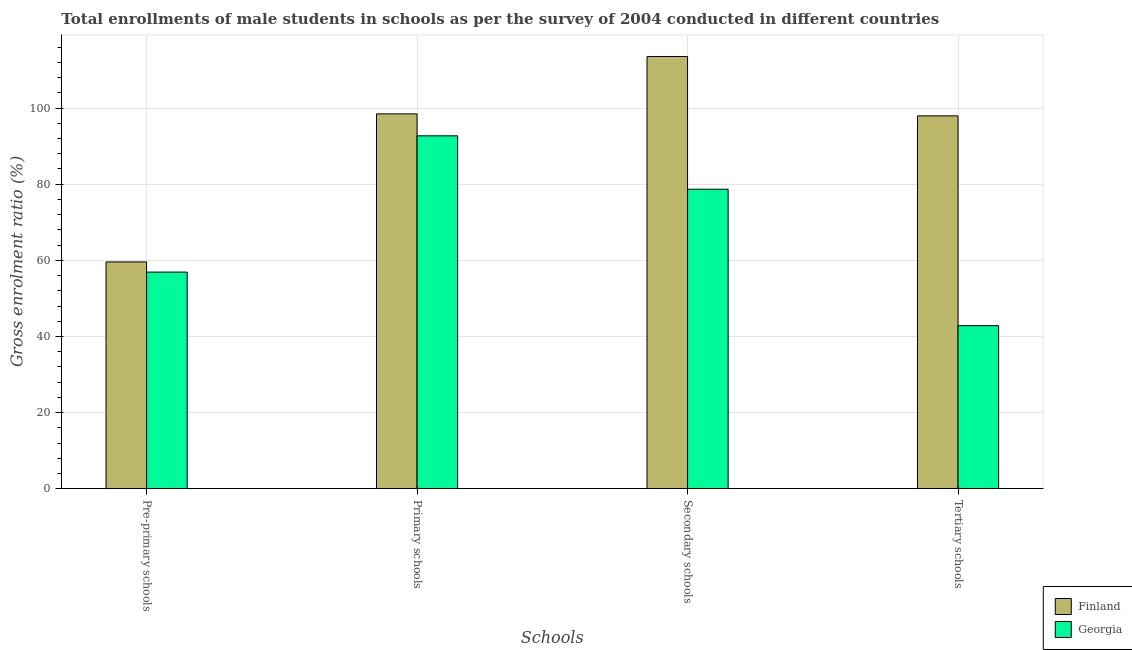How many groups of bars are there?
Make the answer very short. 4. Are the number of bars on each tick of the X-axis equal?
Your answer should be compact. Yes. How many bars are there on the 2nd tick from the right?
Provide a succinct answer. 2. What is the label of the 4th group of bars from the left?
Give a very brief answer. Tertiary schools. What is the gross enrolment ratio(male) in secondary schools in Finland?
Make the answer very short. 113.57. Across all countries, what is the maximum gross enrolment ratio(male) in primary schools?
Give a very brief answer. 98.49. Across all countries, what is the minimum gross enrolment ratio(male) in secondary schools?
Give a very brief answer. 78.69. In which country was the gross enrolment ratio(male) in tertiary schools maximum?
Provide a short and direct response. Finland. In which country was the gross enrolment ratio(male) in primary schools minimum?
Ensure brevity in your answer.  Georgia. What is the total gross enrolment ratio(male) in primary schools in the graph?
Keep it short and to the point. 191.2. What is the difference between the gross enrolment ratio(male) in tertiary schools in Georgia and that in Finland?
Keep it short and to the point. -55.13. What is the difference between the gross enrolment ratio(male) in secondary schools in Finland and the gross enrolment ratio(male) in pre-primary schools in Georgia?
Make the answer very short. 56.66. What is the average gross enrolment ratio(male) in primary schools per country?
Provide a succinct answer. 95.6. What is the difference between the gross enrolment ratio(male) in secondary schools and gross enrolment ratio(male) in tertiary schools in Finland?
Provide a short and direct response. 15.6. In how many countries, is the gross enrolment ratio(male) in primary schools greater than 48 %?
Ensure brevity in your answer.  2. What is the ratio of the gross enrolment ratio(male) in pre-primary schools in Finland to that in Georgia?
Your response must be concise. 1.05. Is the gross enrolment ratio(male) in primary schools in Finland less than that in Georgia?
Your response must be concise. No. What is the difference between the highest and the second highest gross enrolment ratio(male) in primary schools?
Provide a succinct answer. 5.77. What is the difference between the highest and the lowest gross enrolment ratio(male) in pre-primary schools?
Provide a short and direct response. 2.68. Is it the case that in every country, the sum of the gross enrolment ratio(male) in pre-primary schools and gross enrolment ratio(male) in primary schools is greater than the sum of gross enrolment ratio(male) in secondary schools and gross enrolment ratio(male) in tertiary schools?
Offer a terse response. No. What does the 1st bar from the left in Primary schools represents?
Provide a succinct answer. Finland. What does the 2nd bar from the right in Primary schools represents?
Ensure brevity in your answer.  Finland. How many bars are there?
Provide a succinct answer. 8. Are all the bars in the graph horizontal?
Offer a terse response. No. What is the difference between two consecutive major ticks on the Y-axis?
Give a very brief answer. 20. Where does the legend appear in the graph?
Ensure brevity in your answer.  Bottom right. How are the legend labels stacked?
Give a very brief answer. Vertical. What is the title of the graph?
Provide a short and direct response. Total enrollments of male students in schools as per the survey of 2004 conducted in different countries. What is the label or title of the X-axis?
Provide a succinct answer. Schools. What is the label or title of the Y-axis?
Give a very brief answer. Gross enrolment ratio (%). What is the Gross enrolment ratio (%) in Finland in Pre-primary schools?
Keep it short and to the point. 59.58. What is the Gross enrolment ratio (%) in Georgia in Pre-primary schools?
Provide a succinct answer. 56.91. What is the Gross enrolment ratio (%) in Finland in Primary schools?
Provide a short and direct response. 98.49. What is the Gross enrolment ratio (%) in Georgia in Primary schools?
Ensure brevity in your answer.  92.72. What is the Gross enrolment ratio (%) of Finland in Secondary schools?
Provide a succinct answer. 113.57. What is the Gross enrolment ratio (%) in Georgia in Secondary schools?
Provide a succinct answer. 78.69. What is the Gross enrolment ratio (%) in Finland in Tertiary schools?
Offer a terse response. 97.96. What is the Gross enrolment ratio (%) in Georgia in Tertiary schools?
Offer a very short reply. 42.83. Across all Schools, what is the maximum Gross enrolment ratio (%) in Finland?
Your response must be concise. 113.57. Across all Schools, what is the maximum Gross enrolment ratio (%) in Georgia?
Keep it short and to the point. 92.72. Across all Schools, what is the minimum Gross enrolment ratio (%) in Finland?
Give a very brief answer. 59.58. Across all Schools, what is the minimum Gross enrolment ratio (%) in Georgia?
Offer a very short reply. 42.83. What is the total Gross enrolment ratio (%) in Finland in the graph?
Offer a terse response. 369.59. What is the total Gross enrolment ratio (%) of Georgia in the graph?
Provide a succinct answer. 271.15. What is the difference between the Gross enrolment ratio (%) of Finland in Pre-primary schools and that in Primary schools?
Ensure brevity in your answer.  -38.9. What is the difference between the Gross enrolment ratio (%) in Georgia in Pre-primary schools and that in Primary schools?
Provide a succinct answer. -35.81. What is the difference between the Gross enrolment ratio (%) of Finland in Pre-primary schools and that in Secondary schools?
Give a very brief answer. -53.98. What is the difference between the Gross enrolment ratio (%) in Georgia in Pre-primary schools and that in Secondary schools?
Your answer should be compact. -21.78. What is the difference between the Gross enrolment ratio (%) of Finland in Pre-primary schools and that in Tertiary schools?
Your answer should be very brief. -38.38. What is the difference between the Gross enrolment ratio (%) of Georgia in Pre-primary schools and that in Tertiary schools?
Your response must be concise. 14.07. What is the difference between the Gross enrolment ratio (%) of Finland in Primary schools and that in Secondary schools?
Make the answer very short. -15.08. What is the difference between the Gross enrolment ratio (%) of Georgia in Primary schools and that in Secondary schools?
Provide a succinct answer. 14.03. What is the difference between the Gross enrolment ratio (%) in Finland in Primary schools and that in Tertiary schools?
Provide a succinct answer. 0.53. What is the difference between the Gross enrolment ratio (%) of Georgia in Primary schools and that in Tertiary schools?
Keep it short and to the point. 49.89. What is the difference between the Gross enrolment ratio (%) in Finland in Secondary schools and that in Tertiary schools?
Provide a short and direct response. 15.61. What is the difference between the Gross enrolment ratio (%) in Georgia in Secondary schools and that in Tertiary schools?
Your answer should be very brief. 35.86. What is the difference between the Gross enrolment ratio (%) in Finland in Pre-primary schools and the Gross enrolment ratio (%) in Georgia in Primary schools?
Provide a short and direct response. -33.14. What is the difference between the Gross enrolment ratio (%) of Finland in Pre-primary schools and the Gross enrolment ratio (%) of Georgia in Secondary schools?
Keep it short and to the point. -19.11. What is the difference between the Gross enrolment ratio (%) in Finland in Pre-primary schools and the Gross enrolment ratio (%) in Georgia in Tertiary schools?
Keep it short and to the point. 16.75. What is the difference between the Gross enrolment ratio (%) in Finland in Primary schools and the Gross enrolment ratio (%) in Georgia in Secondary schools?
Offer a terse response. 19.8. What is the difference between the Gross enrolment ratio (%) in Finland in Primary schools and the Gross enrolment ratio (%) in Georgia in Tertiary schools?
Give a very brief answer. 55.65. What is the difference between the Gross enrolment ratio (%) of Finland in Secondary schools and the Gross enrolment ratio (%) of Georgia in Tertiary schools?
Offer a very short reply. 70.73. What is the average Gross enrolment ratio (%) in Finland per Schools?
Give a very brief answer. 92.4. What is the average Gross enrolment ratio (%) in Georgia per Schools?
Ensure brevity in your answer.  67.79. What is the difference between the Gross enrolment ratio (%) of Finland and Gross enrolment ratio (%) of Georgia in Pre-primary schools?
Ensure brevity in your answer.  2.68. What is the difference between the Gross enrolment ratio (%) of Finland and Gross enrolment ratio (%) of Georgia in Primary schools?
Offer a very short reply. 5.77. What is the difference between the Gross enrolment ratio (%) in Finland and Gross enrolment ratio (%) in Georgia in Secondary schools?
Provide a short and direct response. 34.88. What is the difference between the Gross enrolment ratio (%) in Finland and Gross enrolment ratio (%) in Georgia in Tertiary schools?
Your answer should be compact. 55.13. What is the ratio of the Gross enrolment ratio (%) of Finland in Pre-primary schools to that in Primary schools?
Ensure brevity in your answer.  0.6. What is the ratio of the Gross enrolment ratio (%) of Georgia in Pre-primary schools to that in Primary schools?
Provide a short and direct response. 0.61. What is the ratio of the Gross enrolment ratio (%) in Finland in Pre-primary schools to that in Secondary schools?
Give a very brief answer. 0.52. What is the ratio of the Gross enrolment ratio (%) in Georgia in Pre-primary schools to that in Secondary schools?
Provide a short and direct response. 0.72. What is the ratio of the Gross enrolment ratio (%) in Finland in Pre-primary schools to that in Tertiary schools?
Provide a succinct answer. 0.61. What is the ratio of the Gross enrolment ratio (%) of Georgia in Pre-primary schools to that in Tertiary schools?
Give a very brief answer. 1.33. What is the ratio of the Gross enrolment ratio (%) of Finland in Primary schools to that in Secondary schools?
Make the answer very short. 0.87. What is the ratio of the Gross enrolment ratio (%) of Georgia in Primary schools to that in Secondary schools?
Make the answer very short. 1.18. What is the ratio of the Gross enrolment ratio (%) in Finland in Primary schools to that in Tertiary schools?
Offer a very short reply. 1.01. What is the ratio of the Gross enrolment ratio (%) in Georgia in Primary schools to that in Tertiary schools?
Your answer should be very brief. 2.16. What is the ratio of the Gross enrolment ratio (%) in Finland in Secondary schools to that in Tertiary schools?
Your answer should be compact. 1.16. What is the ratio of the Gross enrolment ratio (%) of Georgia in Secondary schools to that in Tertiary schools?
Make the answer very short. 1.84. What is the difference between the highest and the second highest Gross enrolment ratio (%) in Finland?
Offer a terse response. 15.08. What is the difference between the highest and the second highest Gross enrolment ratio (%) in Georgia?
Give a very brief answer. 14.03. What is the difference between the highest and the lowest Gross enrolment ratio (%) of Finland?
Keep it short and to the point. 53.98. What is the difference between the highest and the lowest Gross enrolment ratio (%) in Georgia?
Offer a terse response. 49.89. 